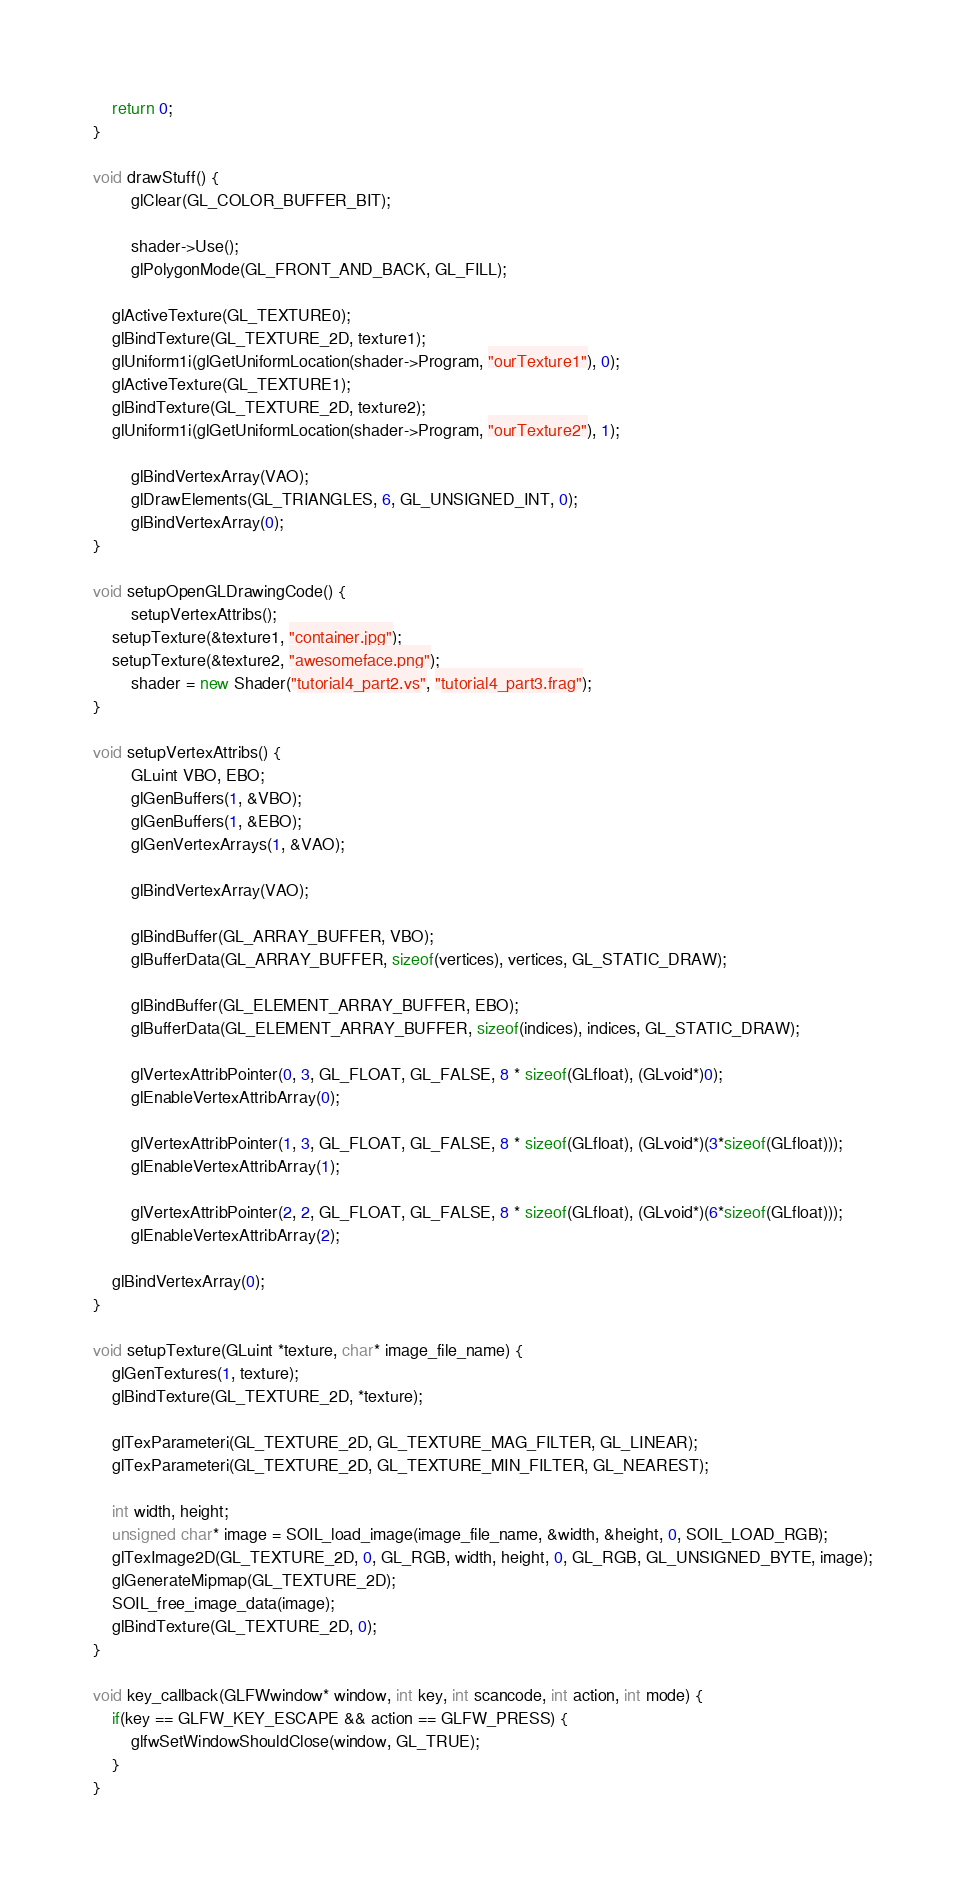Convert code to text. <code><loc_0><loc_0><loc_500><loc_500><_C++_>	return 0;
}

void drawStuff() {
        glClear(GL_COLOR_BUFFER_BIT);
        
        shader->Use();
        glPolygonMode(GL_FRONT_AND_BACK, GL_FILL);

	glActiveTexture(GL_TEXTURE0);
	glBindTexture(GL_TEXTURE_2D, texture1);
	glUniform1i(glGetUniformLocation(shader->Program, "ourTexture1"), 0);
	glActiveTexture(GL_TEXTURE1);
	glBindTexture(GL_TEXTURE_2D, texture2);
	glUniform1i(glGetUniformLocation(shader->Program, "ourTexture2"), 1);
 
        glBindVertexArray(VAO);
        glDrawElements(GL_TRIANGLES, 6, GL_UNSIGNED_INT, 0);
        glBindVertexArray(0);
}

void setupOpenGLDrawingCode() {
        setupVertexAttribs();
	setupTexture(&texture1, "container.jpg");
	setupTexture(&texture2, "awesomeface.png");
        shader = new Shader("tutorial4_part2.vs", "tutorial4_part3.frag");
}

void setupVertexAttribs() {
        GLuint VBO, EBO;
        glGenBuffers(1, &VBO);
        glGenBuffers(1, &EBO);
        glGenVertexArrays(1, &VAO);        
        
        glBindVertexArray(VAO);

        glBindBuffer(GL_ARRAY_BUFFER, VBO);
        glBufferData(GL_ARRAY_BUFFER, sizeof(vertices), vertices, GL_STATIC_DRAW);
        
        glBindBuffer(GL_ELEMENT_ARRAY_BUFFER, EBO);
        glBufferData(GL_ELEMENT_ARRAY_BUFFER, sizeof(indices), indices, GL_STATIC_DRAW);
        
        glVertexAttribPointer(0, 3, GL_FLOAT, GL_FALSE, 8 * sizeof(GLfloat), (GLvoid*)0);
        glEnableVertexAttribArray(0);

        glVertexAttribPointer(1, 3, GL_FLOAT, GL_FALSE, 8 * sizeof(GLfloat), (GLvoid*)(3*sizeof(GLfloat)));
        glEnableVertexAttribArray(1);
        
        glVertexAttribPointer(2, 2, GL_FLOAT, GL_FALSE, 8 * sizeof(GLfloat), (GLvoid*)(6*sizeof(GLfloat)));
        glEnableVertexAttribArray(2);
        
	glBindVertexArray(0);
}

void setupTexture(GLuint *texture, char* image_file_name) {
	glGenTextures(1, texture);
	glBindTexture(GL_TEXTURE_2D, *texture);

	glTexParameteri(GL_TEXTURE_2D, GL_TEXTURE_MAG_FILTER, GL_LINEAR);
	glTexParameteri(GL_TEXTURE_2D, GL_TEXTURE_MIN_FILTER, GL_NEAREST);

	int width, height;
	unsigned char* image = SOIL_load_image(image_file_name, &width, &height, 0, SOIL_LOAD_RGB);
	glTexImage2D(GL_TEXTURE_2D, 0, GL_RGB, width, height, 0, GL_RGB, GL_UNSIGNED_BYTE, image);
	glGenerateMipmap(GL_TEXTURE_2D);
	SOIL_free_image_data(image);
	glBindTexture(GL_TEXTURE_2D, 0);
}

void key_callback(GLFWwindow* window, int key, int scancode, int action, int mode) {
	if(key == GLFW_KEY_ESCAPE && action == GLFW_PRESS) {
		glfwSetWindowShouldClose(window, GL_TRUE);
	}
}
</code> 